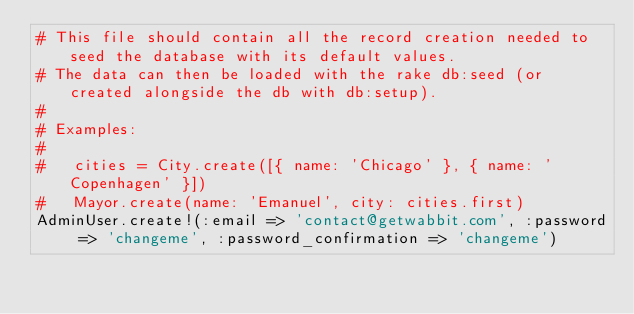Convert code to text. <code><loc_0><loc_0><loc_500><loc_500><_Ruby_># This file should contain all the record creation needed to seed the database with its default values.
# The data can then be loaded with the rake db:seed (or created alongside the db with db:setup).
#
# Examples:
#
#   cities = City.create([{ name: 'Chicago' }, { name: 'Copenhagen' }])
#   Mayor.create(name: 'Emanuel', city: cities.first)
AdminUser.create!(:email => 'contact@getwabbit.com', :password => 'changeme', :password_confirmation => 'changeme')
</code> 